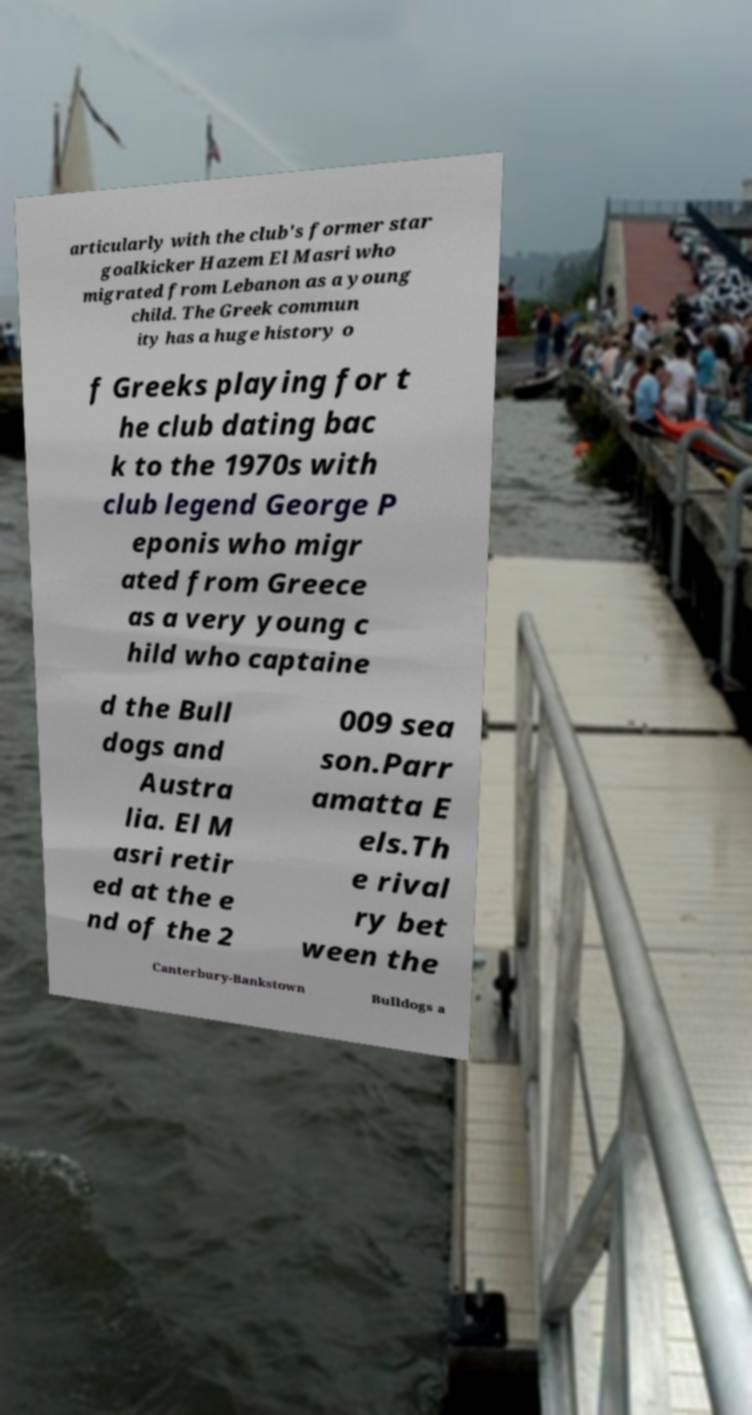Please identify and transcribe the text found in this image. articularly with the club's former star goalkicker Hazem El Masri who migrated from Lebanon as a young child. The Greek commun ity has a huge history o f Greeks playing for t he club dating bac k to the 1970s with club legend George P eponis who migr ated from Greece as a very young c hild who captaine d the Bull dogs and Austra lia. El M asri retir ed at the e nd of the 2 009 sea son.Parr amatta E els.Th e rival ry bet ween the Canterbury-Bankstown Bulldogs a 